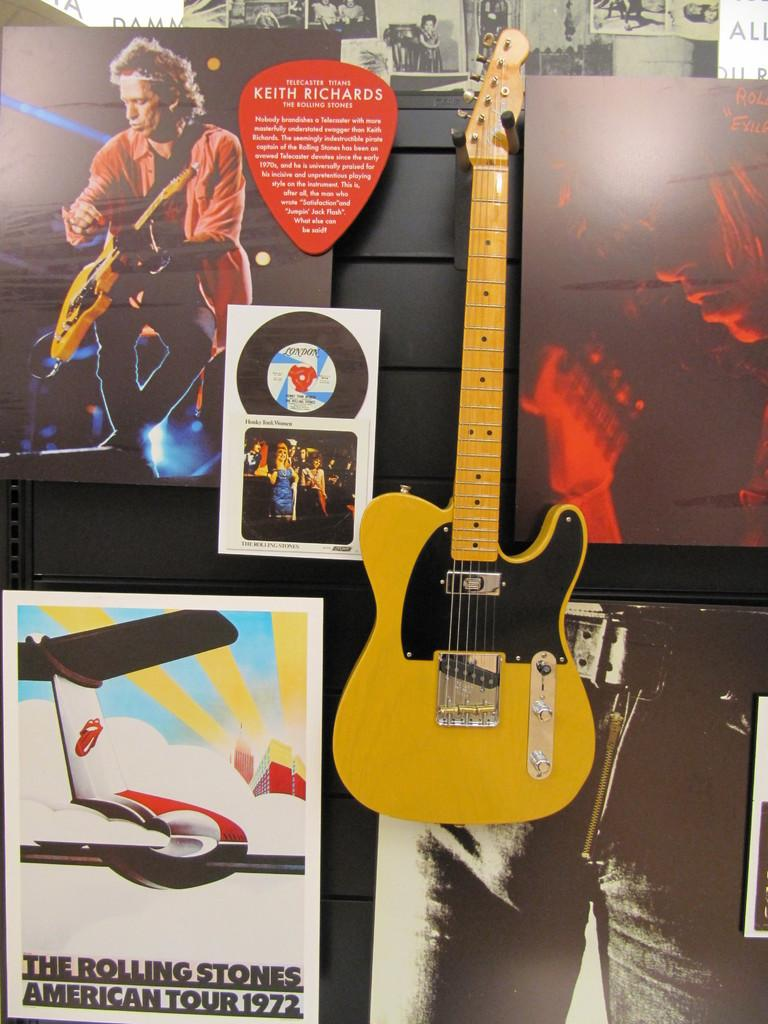What musical instrument is present in the image? There is a guitar in the image. How is the guitar positioned in the image? The guitar is attached to the wall. What type of minister is depicted with the flock of beasts in the image? There is no minister, flock, or beasts present in the image; it only features a guitar attached to the wall. 